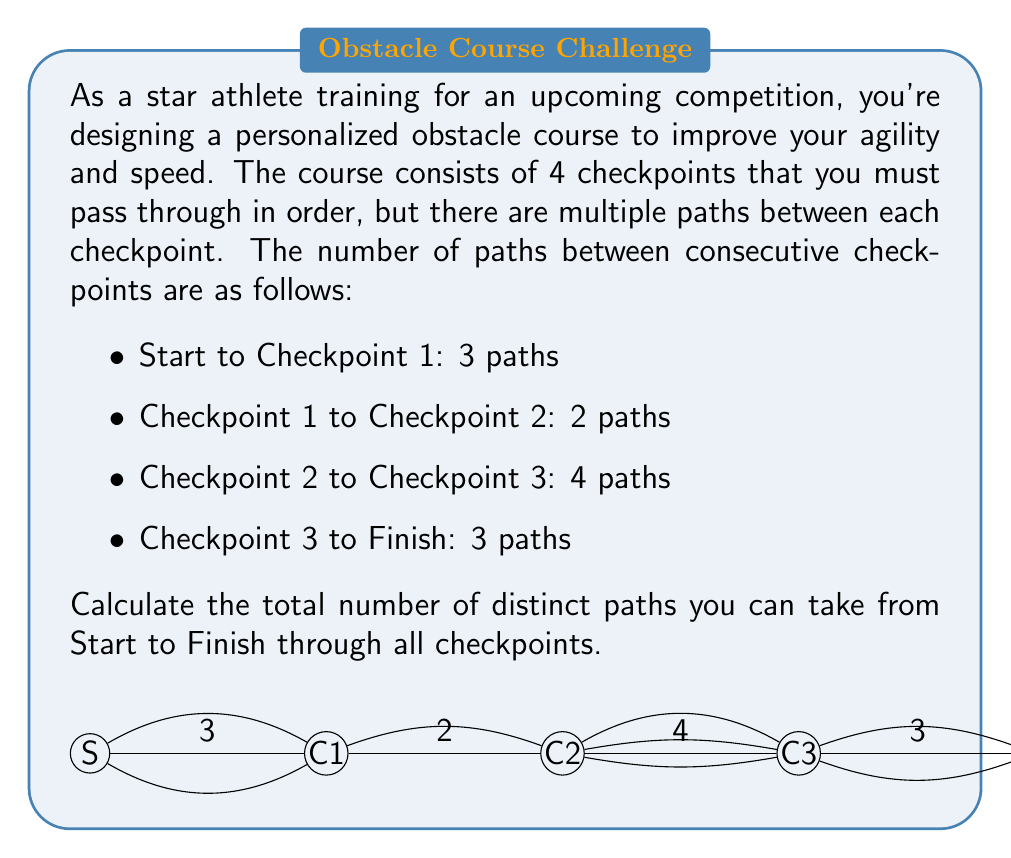Help me with this question. Let's approach this step-by-step using the multiplication principle of counting:

1) The multiplication principle states that if we have a sequence of $n$ choices, where the $i$-th choice has $m_i$ options, then the total number of possible outcomes is the product of all $m_i$.

2) In this case, we have 4 choices to make:
   - Choice 1: Path from Start to Checkpoint 1 (3 options)
   - Choice 2: Path from Checkpoint 1 to Checkpoint 2 (2 options)
   - Choice 3: Path from Checkpoint 2 to Checkpoint 3 (4 options)
   - Choice 4: Path from Checkpoint 3 to Finish (3 options)

3) Each choice is independent of the others, meaning the selection of one path doesn't affect the options for the next path.

4) Therefore, we can apply the multiplication principle:

   Total number of paths = $3 \times 2 \times 4 \times 3$

5) Let's calculate:
   $3 \times 2 = 6$
   $6 \times 4 = 24$
   $24 \times 3 = 72$

Thus, there are 72 distinct paths through the obstacle course.
Answer: 72 